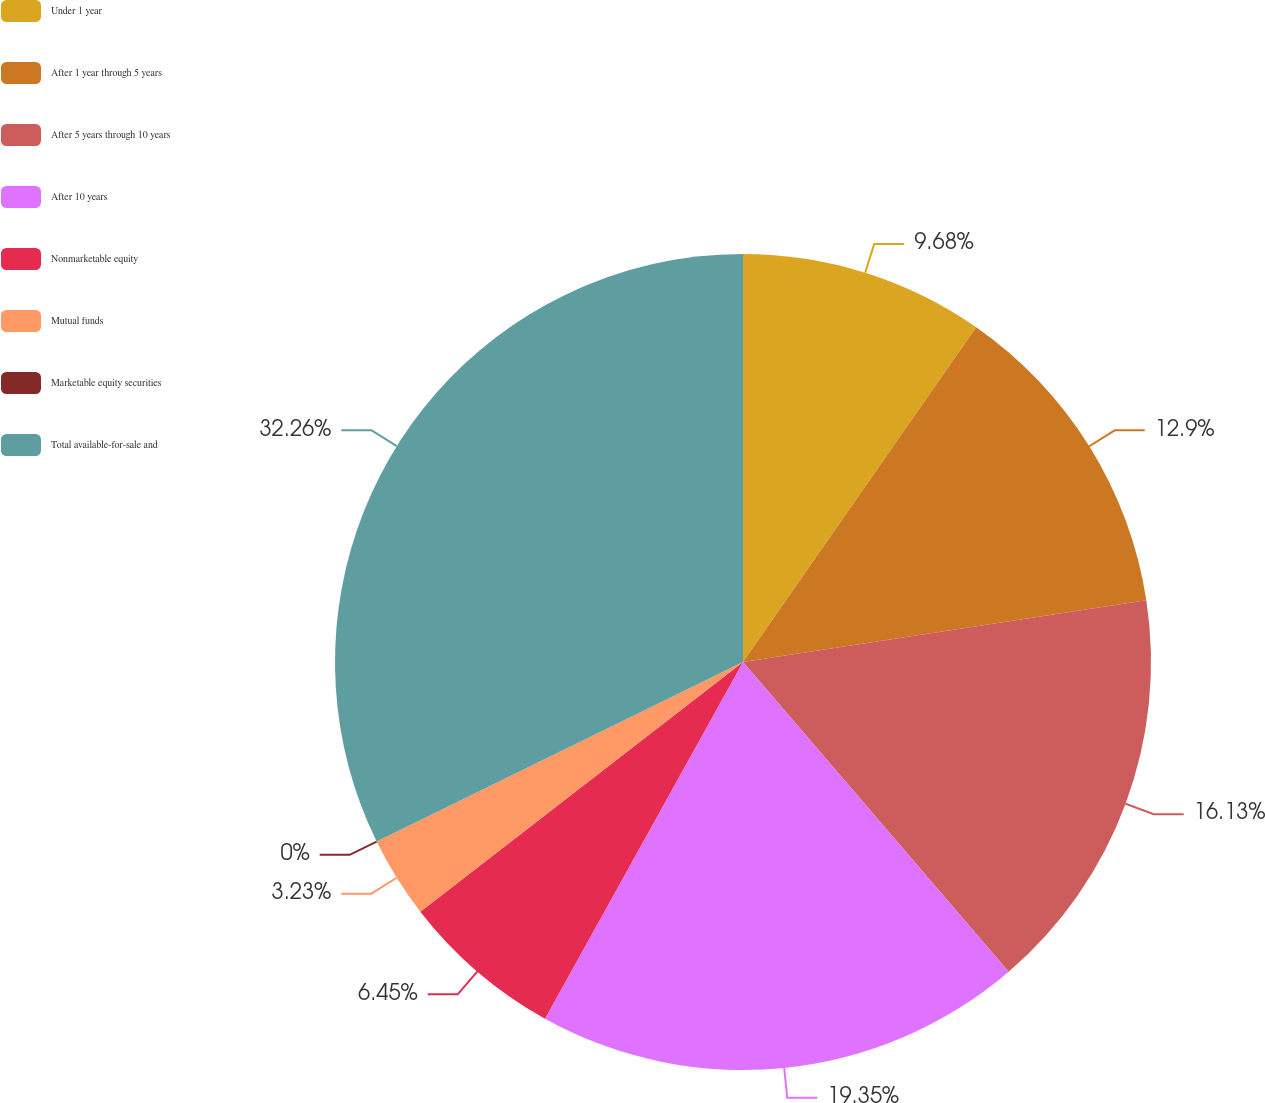Convert chart. <chart><loc_0><loc_0><loc_500><loc_500><pie_chart><fcel>Under 1 year<fcel>After 1 year through 5 years<fcel>After 5 years through 10 years<fcel>After 10 years<fcel>Nonmarketable equity<fcel>Mutual funds<fcel>Marketable equity securities<fcel>Total available-for-sale and<nl><fcel>9.68%<fcel>12.9%<fcel>16.13%<fcel>19.35%<fcel>6.45%<fcel>3.23%<fcel>0.0%<fcel>32.25%<nl></chart> 